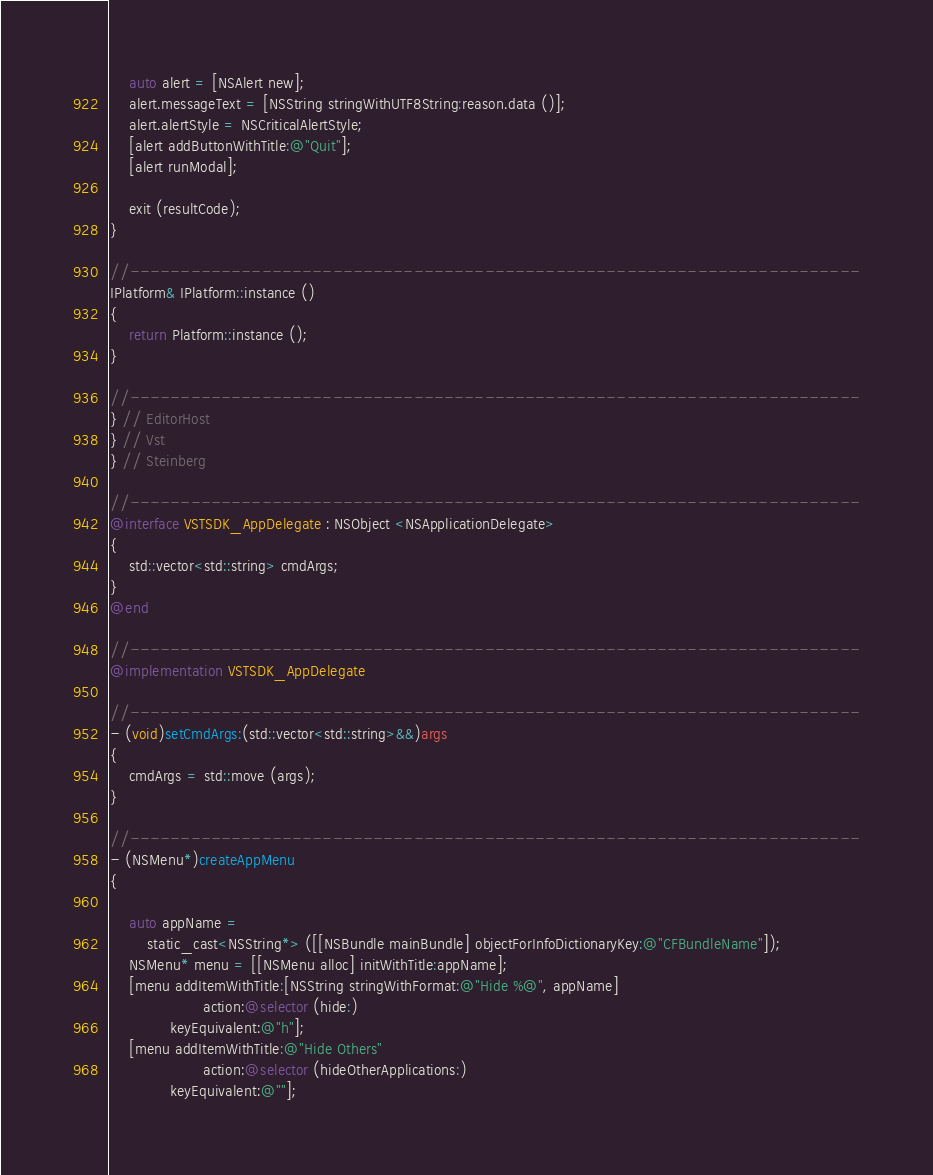<code> <loc_0><loc_0><loc_500><loc_500><_ObjectiveC_>	auto alert = [NSAlert new];
	alert.messageText = [NSString stringWithUTF8String:reason.data ()];
	alert.alertStyle = NSCriticalAlertStyle;
	[alert addButtonWithTitle:@"Quit"];
	[alert runModal];

	exit (resultCode);
}

//------------------------------------------------------------------------
IPlatform& IPlatform::instance ()
{
	return Platform::instance ();
}

//------------------------------------------------------------------------
} // EditorHost
} // Vst
} // Steinberg

//------------------------------------------------------------------------
@interface VSTSDK_AppDelegate : NSObject <NSApplicationDelegate>
{
	std::vector<std::string> cmdArgs;
}
@end

//------------------------------------------------------------------------
@implementation VSTSDK_AppDelegate

//------------------------------------------------------------------------
- (void)setCmdArgs:(std::vector<std::string>&&)args
{
	cmdArgs = std::move (args);
}

//------------------------------------------------------------------------
- (NSMenu*)createAppMenu
{

	auto appName =
	    static_cast<NSString*> ([[NSBundle mainBundle] objectForInfoDictionaryKey:@"CFBundleName"]);
	NSMenu* menu = [[NSMenu alloc] initWithTitle:appName];
	[menu addItemWithTitle:[NSString stringWithFormat:@"Hide %@", appName]
	                action:@selector (hide:)
	         keyEquivalent:@"h"];
	[menu addItemWithTitle:@"Hide Others"
	                action:@selector (hideOtherApplications:)
	         keyEquivalent:@""];</code> 